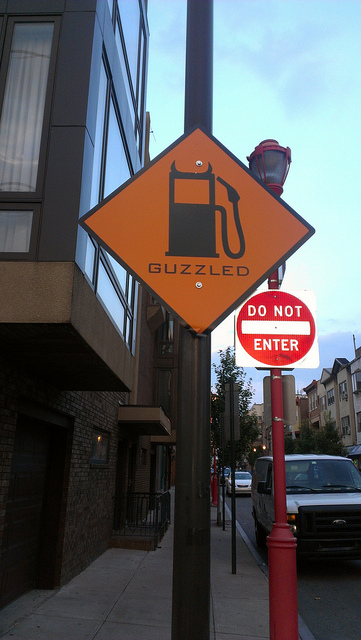Identify the text displayed in this image. GUZZLED DO NOT ENTER 